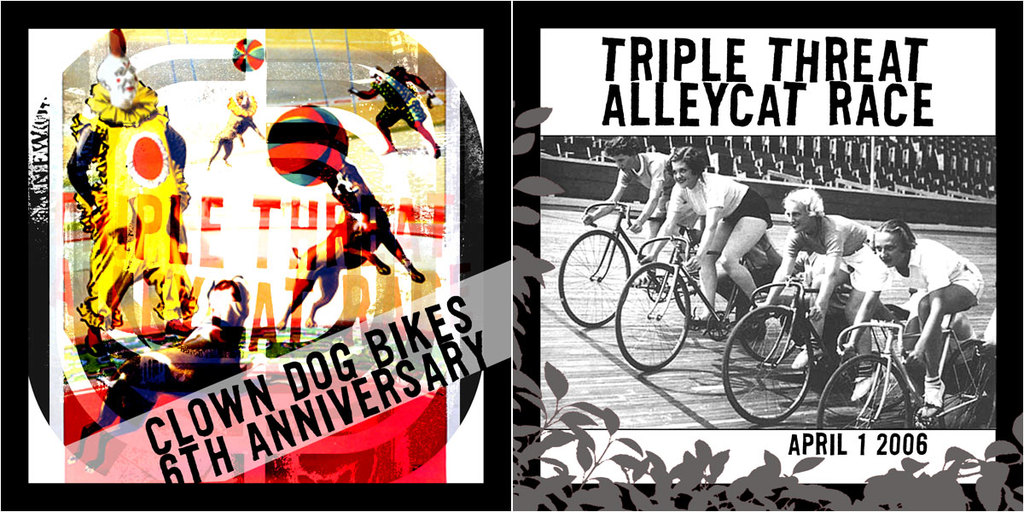Provide a one-sentence caption for the provided image. The vibrant image highlights the 6th anniversary of the Triple Threat Alleycat Race, showcasing elements like clown performances and biking, all set for April 1, 2006. 